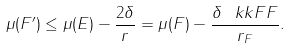Convert formula to latex. <formula><loc_0><loc_0><loc_500><loc_500>\mu ( F ^ { \prime } ) \leq \mu ( E ) - \frac { 2 \delta } { r } = \mu ( F ) - \frac { \delta \, \ k k { F } { F } } { r _ { F } } .</formula> 